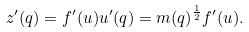<formula> <loc_0><loc_0><loc_500><loc_500>z ^ { \prime } ( q ) = f ^ { \prime } ( u ) u ^ { \prime } ( q ) = m ( q ) ^ { \frac { 1 } { 2 } } f ^ { \prime } ( u ) .</formula> 